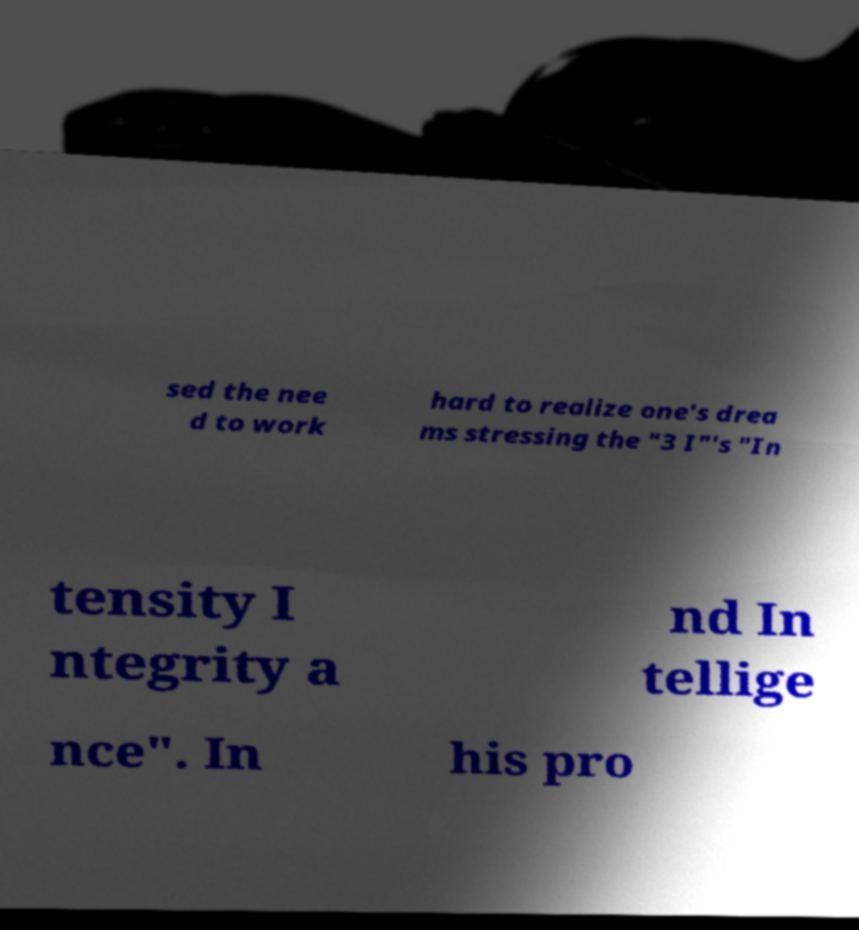What messages or text are displayed in this image? I need them in a readable, typed format. sed the nee d to work hard to realize one's drea ms stressing the "3 I"'s "In tensity I ntegrity a nd In tellige nce". In his pro 